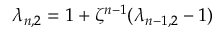<formula> <loc_0><loc_0><loc_500><loc_500>\lambda _ { n , 2 } = 1 + \zeta ^ { n - 1 } ( \lambda _ { { n - 1 } , 2 } - 1 )</formula> 